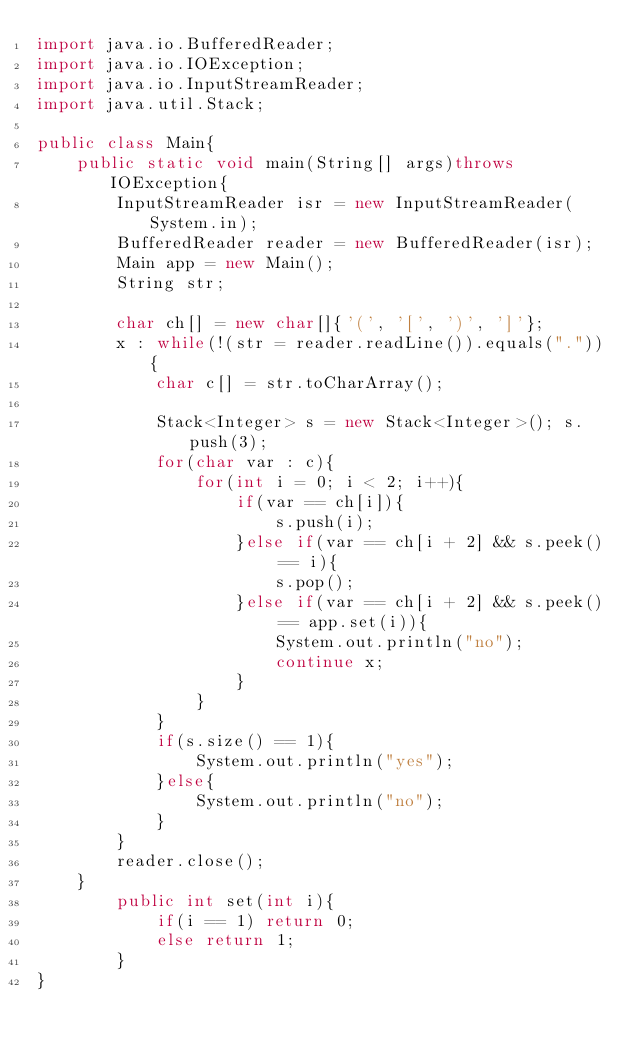Convert code to text. <code><loc_0><loc_0><loc_500><loc_500><_Java_>import java.io.BufferedReader;
import java.io.IOException;
import java.io.InputStreamReader;
import java.util.Stack;

public class Main{
	public static void main(String[] args)throws IOException{
		InputStreamReader isr = new InputStreamReader(System.in);
		BufferedReader reader = new BufferedReader(isr);
		Main app = new Main();
		String str;
		
		char ch[] = new char[]{'(', '[', ')', ']'};
		x : while(!(str = reader.readLine()).equals(".")){
			char c[] = str.toCharArray();
			
			Stack<Integer> s = new Stack<Integer>(); s.push(3);
			for(char var : c){
				for(int i = 0; i < 2; i++){
					if(var == ch[i]){
						s.push(i);
					}else if(var == ch[i + 2] && s.peek() == i){
						s.pop();
					}else if(var == ch[i + 2] && s.peek() == app.set(i)){
						System.out.println("no");
						continue x;
					}
				}
			}
			if(s.size() == 1){
				System.out.println("yes");
			}else{
				System.out.println("no");
			}
		}
		reader.close();
	}
		public int set(int i){
			if(i == 1) return 0;
			else return 1;
		}
}</code> 